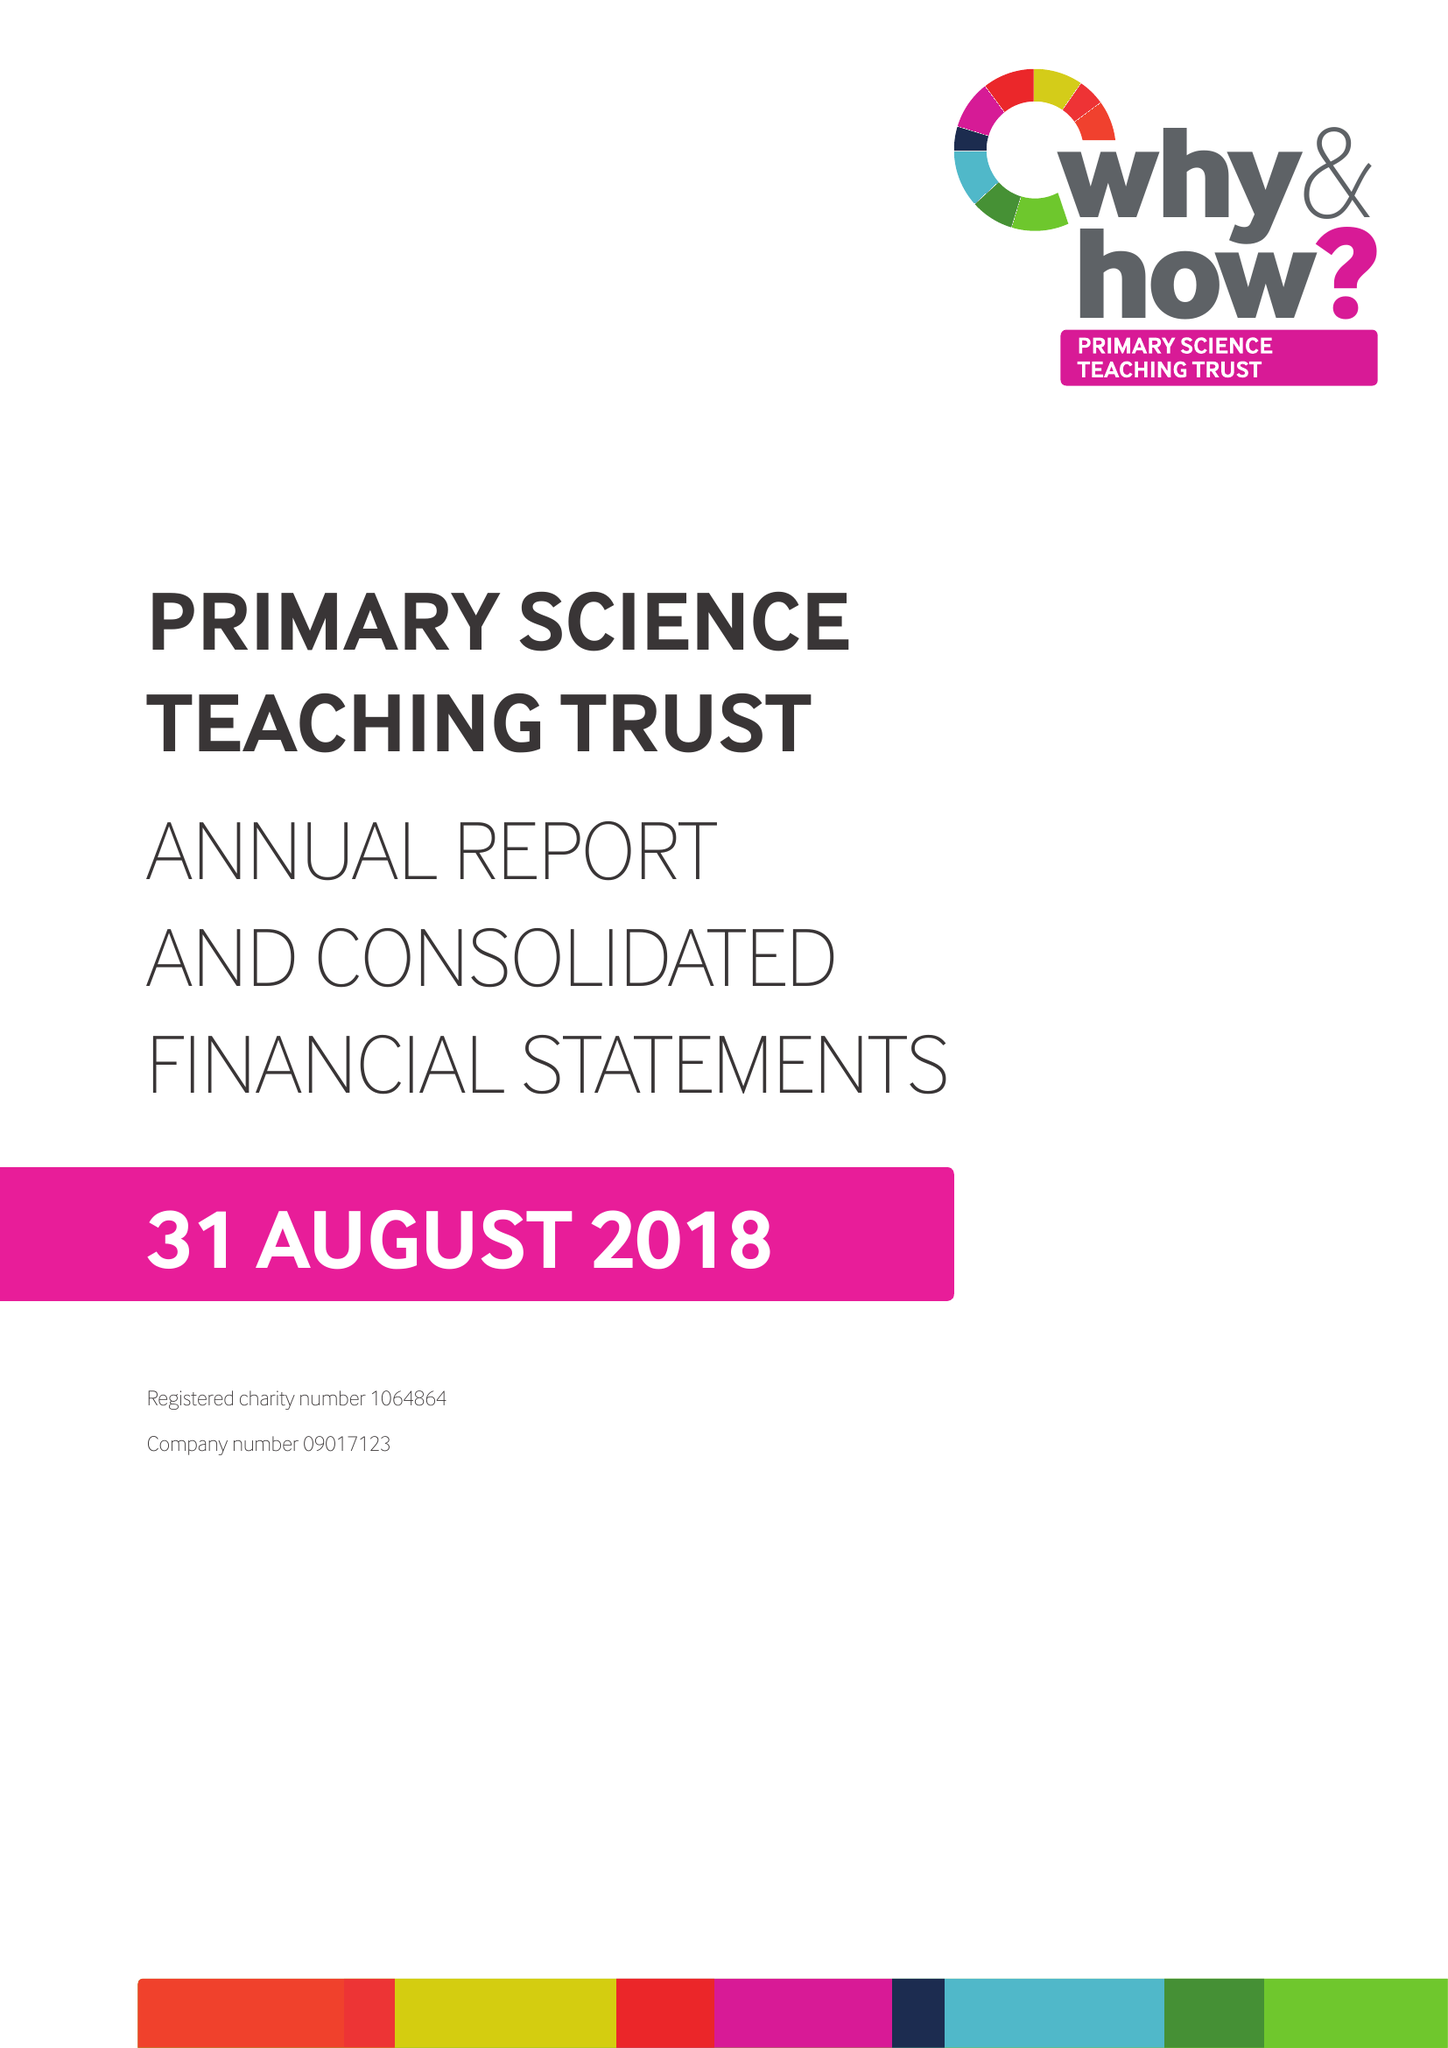What is the value for the charity_number?
Answer the question using a single word or phrase. 1064864 